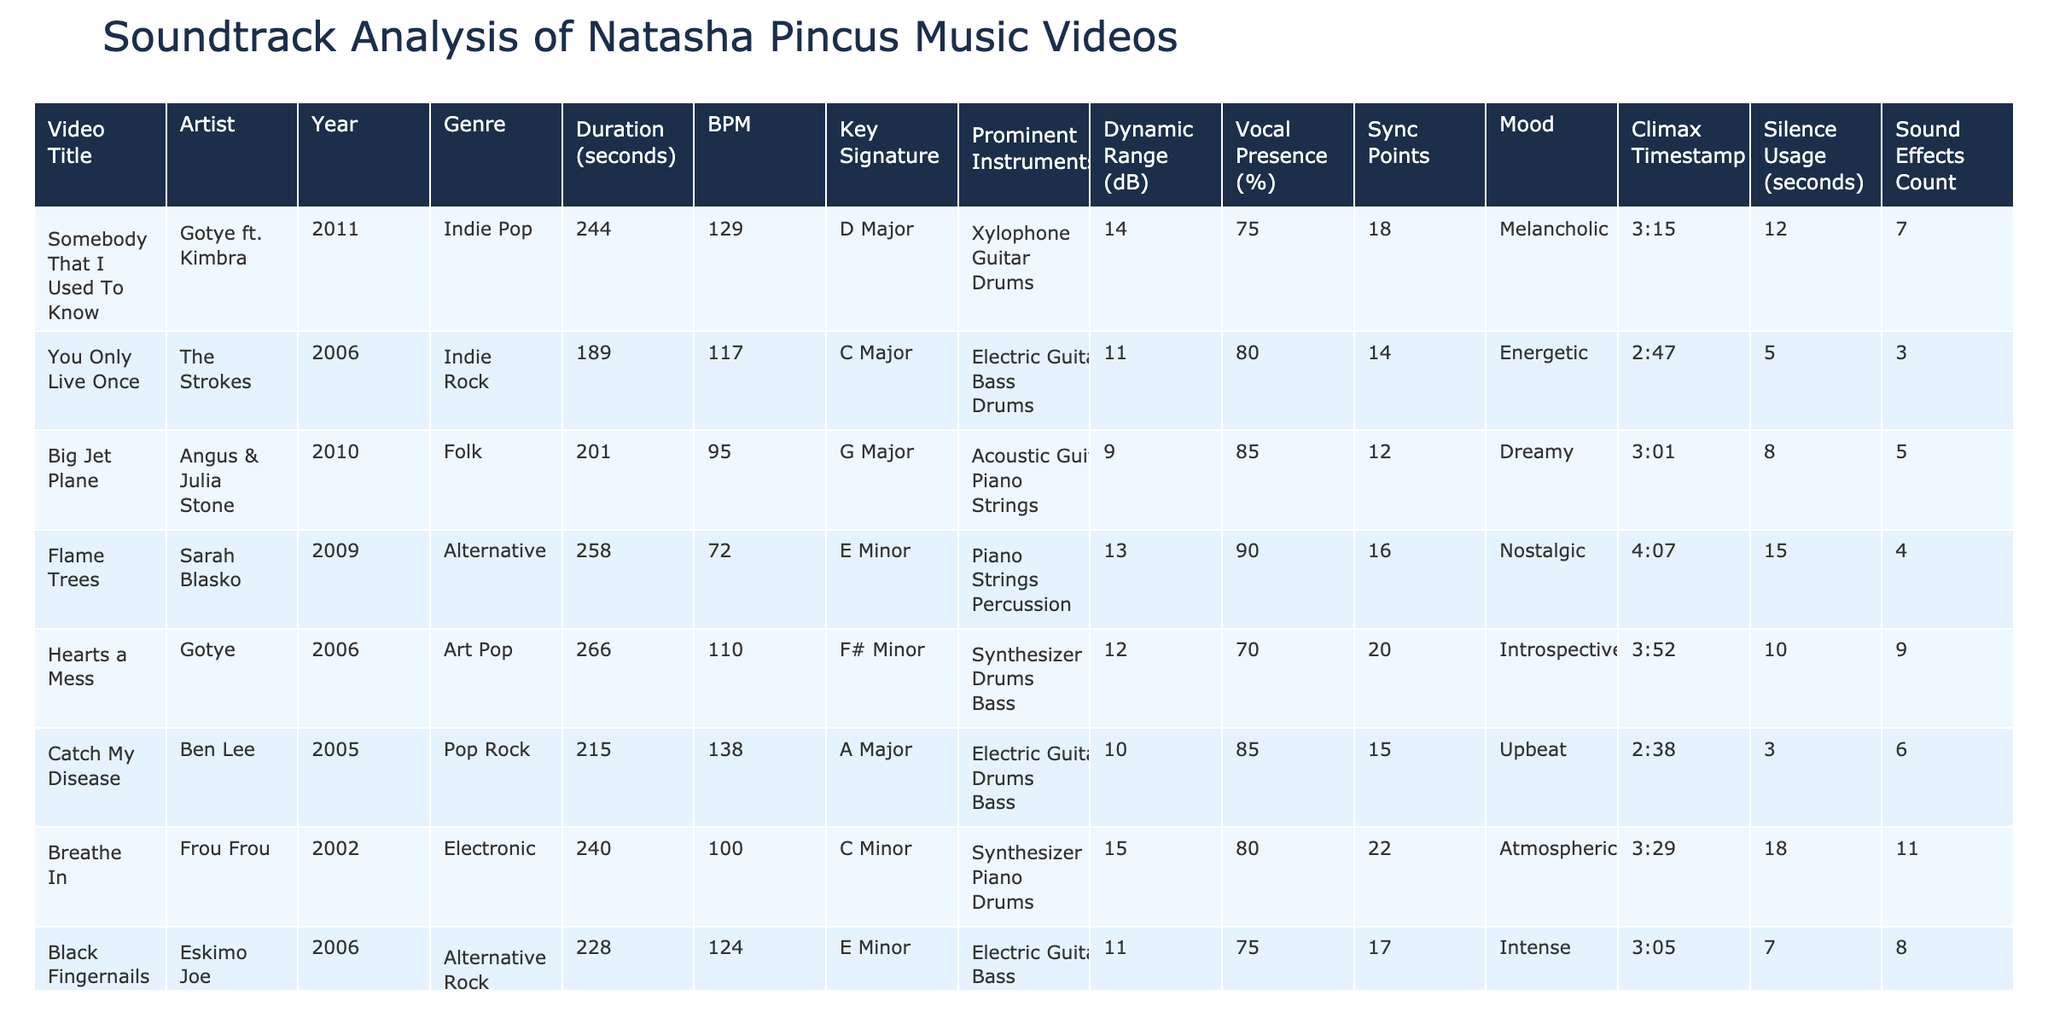What is the duration of the video "Somebody That I Used To Know"? The duration of "Somebody That I Used To Know" is listed under the Duration column, which shows 244 seconds.
Answer: 244 seconds Which video has the highest dynamic range? By comparing the Dynamic Range values from all entries, "Breathe In" has the highest dynamic range at 15 dB.
Answer: 15 dB What is the key signature of "Big Jet Plane"? The key signature for "Big Jet Plane" can be found in its respective row under the Key Signature column, which states G Major.
Answer: G Major How many videos were released in 2011? The table shows two videos released in 2011: "Somebody That I Used To Know" and "Sanctuary." Thus, the total count is 2.
Answer: 2 What is the average BPM of all the videos? The BPM values are 129, 117, 95, 72, 110, 138, 100, 124, 118. Adding them gives 1,198 and dividing by 9 gives an average of approximately 133.11.
Answer: 133.11 Is "Catch My Disease" more upbeat than "Flame Trees"? "Catch My Disease" is characterized as Upbeat (from the Mood column), while "Flame Trees" is Nostalgic. Therefore, it is true that "Catch My Disease" is more upbeat.
Answer: Yes Which video's climax occurs at the latest timestamp? By comparing the Climax Timestamps, "Flame Trees" has the climax at 4:07, which is the latest among all entries.
Answer: 4:07 How many sound effects are used in "Breathe In"? Under the Sound Effects Count column, "Breathe In" is shown to have a total of 11 sound effects.
Answer: 11 Which instrument is most commonly found across the videos? By reviewing the prominent instruments, Electric Guitar appears in the most entries: "You Only Live Once," "Catch My Disease," and "Black Fingernails Red Wine." It is thus the most common.
Answer: Electric Guitar What is the total silence usage in seconds for all videos? Adding up the Silence Usage values: 12 + 5 + 8 + 15 + 10 + 3 + 18 + 7 + 6 gives a total of 84 seconds.
Answer: 84 seconds Which video is the longest in duration, and what is its length? The longest video is "Hearts a Mess" with a duration of 266 seconds, identified by comparing all duration values.
Answer: Hearts a Mess, 266 seconds What genre does the video "Sanctuary" belong to? The genre for "Sanctuary" is listed under the Genre column, which describes it as Indie Pop.
Answer: Indie Pop 